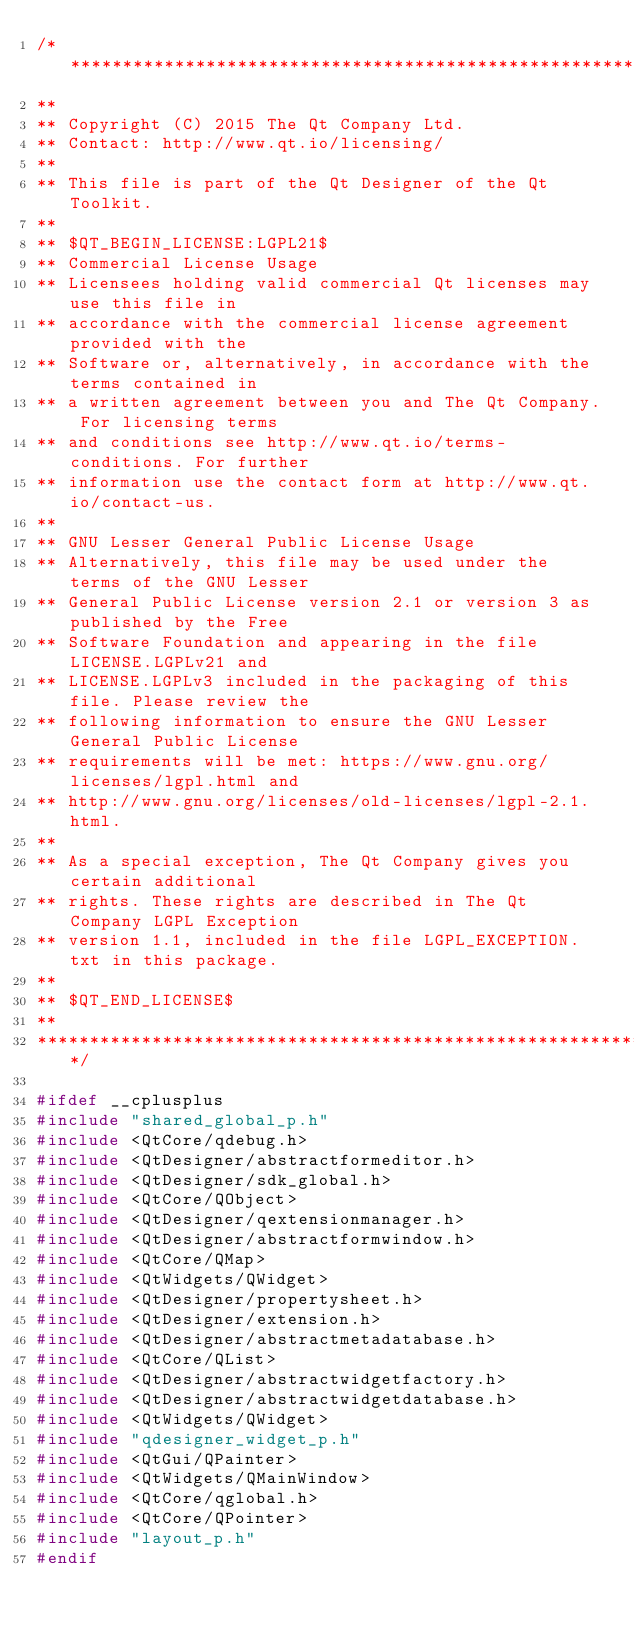<code> <loc_0><loc_0><loc_500><loc_500><_C_>/****************************************************************************
**
** Copyright (C) 2015 The Qt Company Ltd.
** Contact: http://www.qt.io/licensing/
**
** This file is part of the Qt Designer of the Qt Toolkit.
**
** $QT_BEGIN_LICENSE:LGPL21$
** Commercial License Usage
** Licensees holding valid commercial Qt licenses may use this file in
** accordance with the commercial license agreement provided with the
** Software or, alternatively, in accordance with the terms contained in
** a written agreement between you and The Qt Company. For licensing terms
** and conditions see http://www.qt.io/terms-conditions. For further
** information use the contact form at http://www.qt.io/contact-us.
**
** GNU Lesser General Public License Usage
** Alternatively, this file may be used under the terms of the GNU Lesser
** General Public License version 2.1 or version 3 as published by the Free
** Software Foundation and appearing in the file LICENSE.LGPLv21 and
** LICENSE.LGPLv3 included in the packaging of this file. Please review the
** following information to ensure the GNU Lesser General Public License
** requirements will be met: https://www.gnu.org/licenses/lgpl.html and
** http://www.gnu.org/licenses/old-licenses/lgpl-2.1.html.
**
** As a special exception, The Qt Company gives you certain additional
** rights. These rights are described in The Qt Company LGPL Exception
** version 1.1, included in the file LGPL_EXCEPTION.txt in this package.
**
** $QT_END_LICENSE$
**
****************************************************************************/

#ifdef __cplusplus
#include "shared_global_p.h"
#include <QtCore/qdebug.h>
#include <QtDesigner/abstractformeditor.h>
#include <QtDesigner/sdk_global.h>
#include <QtCore/QObject>
#include <QtDesigner/qextensionmanager.h>
#include <QtDesigner/abstractformwindow.h>
#include <QtCore/QMap>
#include <QtWidgets/QWidget>
#include <QtDesigner/propertysheet.h>
#include <QtDesigner/extension.h>
#include <QtDesigner/abstractmetadatabase.h>
#include <QtCore/QList>
#include <QtDesigner/abstractwidgetfactory.h>
#include <QtDesigner/abstractwidgetdatabase.h>
#include <QtWidgets/QWidget>
#include "qdesigner_widget_p.h"
#include <QtGui/QPainter>
#include <QtWidgets/QMainWindow>
#include <QtCore/qglobal.h>
#include <QtCore/QPointer>
#include "layout_p.h"
#endif
</code> 